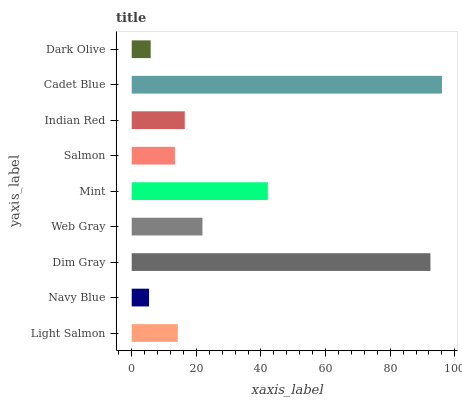Is Navy Blue the minimum?
Answer yes or no. Yes. Is Cadet Blue the maximum?
Answer yes or no. Yes. Is Dim Gray the minimum?
Answer yes or no. No. Is Dim Gray the maximum?
Answer yes or no. No. Is Dim Gray greater than Navy Blue?
Answer yes or no. Yes. Is Navy Blue less than Dim Gray?
Answer yes or no. Yes. Is Navy Blue greater than Dim Gray?
Answer yes or no. No. Is Dim Gray less than Navy Blue?
Answer yes or no. No. Is Indian Red the high median?
Answer yes or no. Yes. Is Indian Red the low median?
Answer yes or no. Yes. Is Salmon the high median?
Answer yes or no. No. Is Salmon the low median?
Answer yes or no. No. 